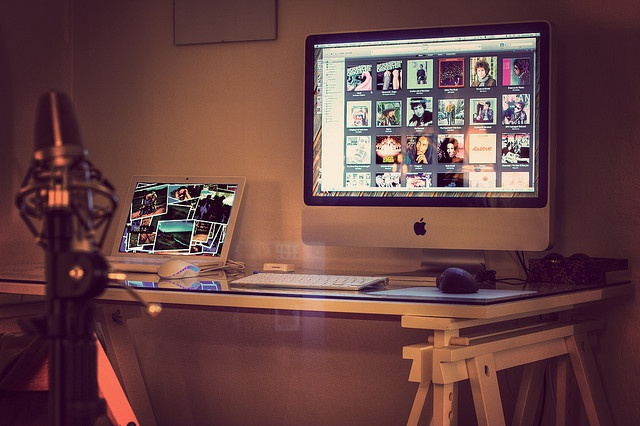Describe the objects in this image and their specific colors. I can see tv in black, beige, brown, and gray tones, laptop in black, brown, gray, and ivory tones, keyboard in black, tan, darkgray, gray, and brown tones, mouse in black and purple tones, and mouse in black, salmon, and tan tones in this image. 